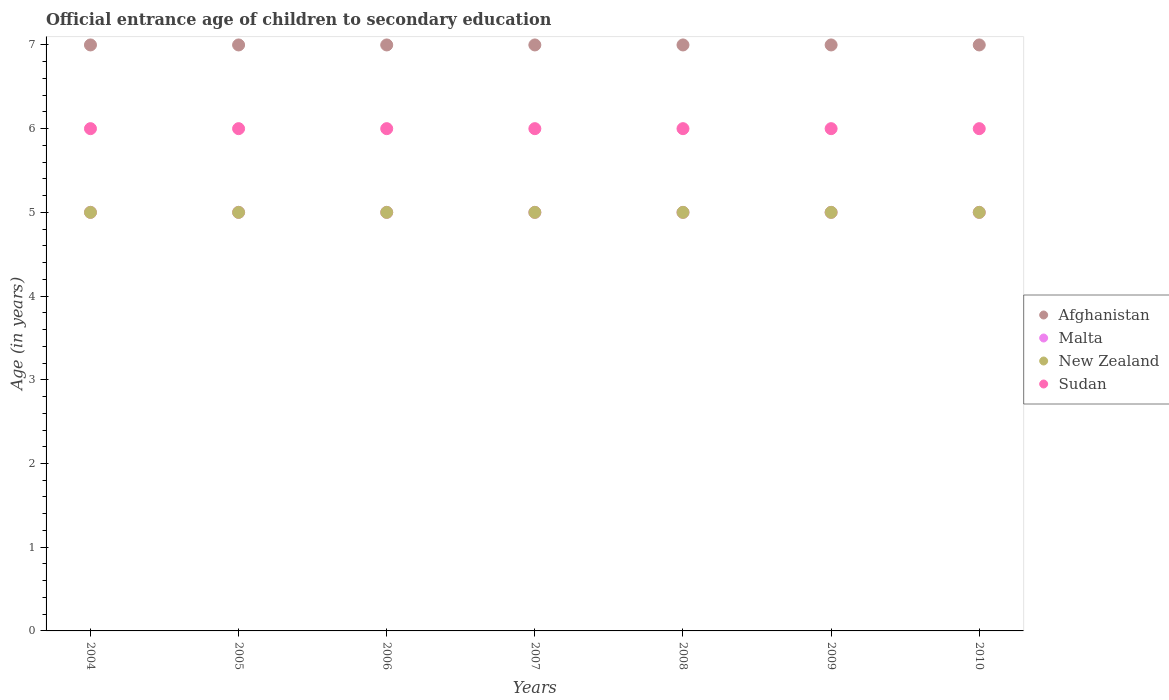Is the number of dotlines equal to the number of legend labels?
Provide a succinct answer. Yes. What is the secondary school starting age of children in Malta in 2010?
Keep it short and to the point. 5. Across all years, what is the maximum secondary school starting age of children in Malta?
Offer a terse response. 5. Across all years, what is the minimum secondary school starting age of children in Sudan?
Provide a succinct answer. 6. What is the total secondary school starting age of children in Afghanistan in the graph?
Provide a succinct answer. 49. In the year 2006, what is the difference between the secondary school starting age of children in Afghanistan and secondary school starting age of children in Sudan?
Make the answer very short. 1. What is the ratio of the secondary school starting age of children in Afghanistan in 2004 to that in 2008?
Your answer should be very brief. 1. Is the secondary school starting age of children in New Zealand in 2008 less than that in 2010?
Provide a short and direct response. No. In how many years, is the secondary school starting age of children in Malta greater than the average secondary school starting age of children in Malta taken over all years?
Offer a terse response. 0. Is the sum of the secondary school starting age of children in New Zealand in 2008 and 2010 greater than the maximum secondary school starting age of children in Sudan across all years?
Ensure brevity in your answer.  Yes. Is it the case that in every year, the sum of the secondary school starting age of children in Malta and secondary school starting age of children in New Zealand  is greater than the sum of secondary school starting age of children in Afghanistan and secondary school starting age of children in Sudan?
Offer a terse response. No. Is it the case that in every year, the sum of the secondary school starting age of children in Malta and secondary school starting age of children in New Zealand  is greater than the secondary school starting age of children in Sudan?
Provide a succinct answer. Yes. Does the secondary school starting age of children in Afghanistan monotonically increase over the years?
Your answer should be compact. No. Is the secondary school starting age of children in Afghanistan strictly greater than the secondary school starting age of children in Malta over the years?
Offer a very short reply. Yes. How many dotlines are there?
Offer a terse response. 4. What is the difference between two consecutive major ticks on the Y-axis?
Provide a succinct answer. 1. Are the values on the major ticks of Y-axis written in scientific E-notation?
Ensure brevity in your answer.  No. Does the graph contain any zero values?
Provide a succinct answer. No. Does the graph contain grids?
Offer a very short reply. No. How many legend labels are there?
Make the answer very short. 4. How are the legend labels stacked?
Give a very brief answer. Vertical. What is the title of the graph?
Your response must be concise. Official entrance age of children to secondary education. What is the label or title of the X-axis?
Give a very brief answer. Years. What is the label or title of the Y-axis?
Make the answer very short. Age (in years). What is the Age (in years) in Afghanistan in 2004?
Ensure brevity in your answer.  7. What is the Age (in years) of Malta in 2004?
Make the answer very short. 5. What is the Age (in years) of New Zealand in 2005?
Ensure brevity in your answer.  5. What is the Age (in years) of Sudan in 2005?
Offer a terse response. 6. What is the Age (in years) in New Zealand in 2006?
Offer a very short reply. 5. What is the Age (in years) in Afghanistan in 2007?
Your response must be concise. 7. What is the Age (in years) of Malta in 2007?
Make the answer very short. 5. What is the Age (in years) of New Zealand in 2007?
Your answer should be very brief. 5. What is the Age (in years) in Sudan in 2007?
Make the answer very short. 6. What is the Age (in years) in Malta in 2008?
Give a very brief answer. 5. What is the Age (in years) of Malta in 2010?
Your response must be concise. 5. What is the Age (in years) of New Zealand in 2010?
Make the answer very short. 5. What is the Age (in years) in Sudan in 2010?
Ensure brevity in your answer.  6. Across all years, what is the maximum Age (in years) in New Zealand?
Offer a very short reply. 5. Across all years, what is the minimum Age (in years) in Afghanistan?
Ensure brevity in your answer.  7. Across all years, what is the minimum Age (in years) of Malta?
Offer a very short reply. 5. Across all years, what is the minimum Age (in years) of New Zealand?
Your response must be concise. 5. What is the total Age (in years) of Afghanistan in the graph?
Your answer should be very brief. 49. What is the total Age (in years) of Malta in the graph?
Your answer should be compact. 35. What is the total Age (in years) in Sudan in the graph?
Offer a very short reply. 42. What is the difference between the Age (in years) of Afghanistan in 2004 and that in 2005?
Your response must be concise. 0. What is the difference between the Age (in years) of New Zealand in 2004 and that in 2005?
Keep it short and to the point. 0. What is the difference between the Age (in years) in Afghanistan in 2004 and that in 2006?
Provide a succinct answer. 0. What is the difference between the Age (in years) of New Zealand in 2004 and that in 2006?
Give a very brief answer. 0. What is the difference between the Age (in years) in New Zealand in 2004 and that in 2007?
Make the answer very short. 0. What is the difference between the Age (in years) of Sudan in 2004 and that in 2007?
Your answer should be very brief. 0. What is the difference between the Age (in years) of Malta in 2004 and that in 2008?
Your answer should be very brief. 0. What is the difference between the Age (in years) of New Zealand in 2004 and that in 2008?
Ensure brevity in your answer.  0. What is the difference between the Age (in years) of Afghanistan in 2004 and that in 2009?
Ensure brevity in your answer.  0. What is the difference between the Age (in years) in Malta in 2004 and that in 2009?
Provide a short and direct response. 0. What is the difference between the Age (in years) of Afghanistan in 2004 and that in 2010?
Your answer should be compact. 0. What is the difference between the Age (in years) of Malta in 2005 and that in 2007?
Your answer should be compact. 0. What is the difference between the Age (in years) in Sudan in 2005 and that in 2007?
Offer a very short reply. 0. What is the difference between the Age (in years) in Malta in 2005 and that in 2008?
Offer a very short reply. 0. What is the difference between the Age (in years) in New Zealand in 2005 and that in 2008?
Offer a terse response. 0. What is the difference between the Age (in years) of Afghanistan in 2005 and that in 2009?
Provide a succinct answer. 0. What is the difference between the Age (in years) of Sudan in 2005 and that in 2009?
Your answer should be very brief. 0. What is the difference between the Age (in years) of Afghanistan in 2005 and that in 2010?
Give a very brief answer. 0. What is the difference between the Age (in years) of Malta in 2005 and that in 2010?
Keep it short and to the point. 0. What is the difference between the Age (in years) of Sudan in 2005 and that in 2010?
Provide a succinct answer. 0. What is the difference between the Age (in years) of Afghanistan in 2006 and that in 2007?
Make the answer very short. 0. What is the difference between the Age (in years) in New Zealand in 2006 and that in 2008?
Give a very brief answer. 0. What is the difference between the Age (in years) of Afghanistan in 2006 and that in 2009?
Keep it short and to the point. 0. What is the difference between the Age (in years) in Afghanistan in 2006 and that in 2010?
Offer a very short reply. 0. What is the difference between the Age (in years) in Malta in 2006 and that in 2010?
Your answer should be compact. 0. What is the difference between the Age (in years) in New Zealand in 2006 and that in 2010?
Provide a succinct answer. 0. What is the difference between the Age (in years) in Afghanistan in 2007 and that in 2008?
Provide a short and direct response. 0. What is the difference between the Age (in years) of Sudan in 2007 and that in 2008?
Give a very brief answer. 0. What is the difference between the Age (in years) of Malta in 2007 and that in 2009?
Ensure brevity in your answer.  0. What is the difference between the Age (in years) in New Zealand in 2007 and that in 2009?
Offer a very short reply. 0. What is the difference between the Age (in years) in Afghanistan in 2007 and that in 2010?
Provide a short and direct response. 0. What is the difference between the Age (in years) of Afghanistan in 2008 and that in 2009?
Offer a very short reply. 0. What is the difference between the Age (in years) of Malta in 2008 and that in 2009?
Your answer should be compact. 0. What is the difference between the Age (in years) in New Zealand in 2008 and that in 2009?
Keep it short and to the point. 0. What is the difference between the Age (in years) of Sudan in 2008 and that in 2009?
Your answer should be very brief. 0. What is the difference between the Age (in years) in Afghanistan in 2008 and that in 2010?
Offer a very short reply. 0. What is the difference between the Age (in years) of Malta in 2008 and that in 2010?
Give a very brief answer. 0. What is the difference between the Age (in years) in New Zealand in 2008 and that in 2010?
Offer a very short reply. 0. What is the difference between the Age (in years) of Sudan in 2008 and that in 2010?
Make the answer very short. 0. What is the difference between the Age (in years) in Malta in 2009 and that in 2010?
Keep it short and to the point. 0. What is the difference between the Age (in years) of Afghanistan in 2004 and the Age (in years) of New Zealand in 2005?
Offer a terse response. 2. What is the difference between the Age (in years) in Malta in 2004 and the Age (in years) in New Zealand in 2005?
Your response must be concise. 0. What is the difference between the Age (in years) of New Zealand in 2004 and the Age (in years) of Sudan in 2005?
Your answer should be compact. -1. What is the difference between the Age (in years) of Afghanistan in 2004 and the Age (in years) of Sudan in 2006?
Your answer should be very brief. 1. What is the difference between the Age (in years) in New Zealand in 2004 and the Age (in years) in Sudan in 2006?
Your answer should be compact. -1. What is the difference between the Age (in years) in Afghanistan in 2004 and the Age (in years) in Sudan in 2007?
Your answer should be very brief. 1. What is the difference between the Age (in years) of Afghanistan in 2004 and the Age (in years) of Malta in 2008?
Your answer should be very brief. 2. What is the difference between the Age (in years) in Afghanistan in 2004 and the Age (in years) in New Zealand in 2008?
Ensure brevity in your answer.  2. What is the difference between the Age (in years) in Afghanistan in 2004 and the Age (in years) in Sudan in 2008?
Offer a terse response. 1. What is the difference between the Age (in years) of Malta in 2004 and the Age (in years) of New Zealand in 2008?
Offer a terse response. 0. What is the difference between the Age (in years) in Malta in 2004 and the Age (in years) in Sudan in 2008?
Ensure brevity in your answer.  -1. What is the difference between the Age (in years) in New Zealand in 2004 and the Age (in years) in Sudan in 2008?
Ensure brevity in your answer.  -1. What is the difference between the Age (in years) of Afghanistan in 2004 and the Age (in years) of Sudan in 2009?
Your answer should be compact. 1. What is the difference between the Age (in years) of Malta in 2004 and the Age (in years) of New Zealand in 2009?
Make the answer very short. 0. What is the difference between the Age (in years) in New Zealand in 2004 and the Age (in years) in Sudan in 2009?
Your answer should be compact. -1. What is the difference between the Age (in years) in Afghanistan in 2004 and the Age (in years) in Malta in 2010?
Keep it short and to the point. 2. What is the difference between the Age (in years) of Afghanistan in 2004 and the Age (in years) of Sudan in 2010?
Offer a terse response. 1. What is the difference between the Age (in years) in New Zealand in 2004 and the Age (in years) in Sudan in 2010?
Your answer should be very brief. -1. What is the difference between the Age (in years) of Afghanistan in 2005 and the Age (in years) of New Zealand in 2006?
Your response must be concise. 2. What is the difference between the Age (in years) of Malta in 2005 and the Age (in years) of New Zealand in 2006?
Your answer should be compact. 0. What is the difference between the Age (in years) in Afghanistan in 2005 and the Age (in years) in Malta in 2007?
Ensure brevity in your answer.  2. What is the difference between the Age (in years) in Malta in 2005 and the Age (in years) in Sudan in 2007?
Provide a succinct answer. -1. What is the difference between the Age (in years) of Afghanistan in 2005 and the Age (in years) of New Zealand in 2008?
Ensure brevity in your answer.  2. What is the difference between the Age (in years) in Afghanistan in 2005 and the Age (in years) in Sudan in 2008?
Offer a very short reply. 1. What is the difference between the Age (in years) of New Zealand in 2005 and the Age (in years) of Sudan in 2008?
Your response must be concise. -1. What is the difference between the Age (in years) in Afghanistan in 2005 and the Age (in years) in Malta in 2009?
Provide a succinct answer. 2. What is the difference between the Age (in years) in Afghanistan in 2005 and the Age (in years) in New Zealand in 2009?
Your answer should be very brief. 2. What is the difference between the Age (in years) in Afghanistan in 2005 and the Age (in years) in Sudan in 2009?
Give a very brief answer. 1. What is the difference between the Age (in years) in Malta in 2005 and the Age (in years) in New Zealand in 2009?
Keep it short and to the point. 0. What is the difference between the Age (in years) in Malta in 2005 and the Age (in years) in Sudan in 2009?
Your answer should be compact. -1. What is the difference between the Age (in years) of Afghanistan in 2006 and the Age (in years) of Sudan in 2007?
Make the answer very short. 1. What is the difference between the Age (in years) of Malta in 2006 and the Age (in years) of New Zealand in 2007?
Keep it short and to the point. 0. What is the difference between the Age (in years) in Afghanistan in 2006 and the Age (in years) in New Zealand in 2008?
Offer a very short reply. 2. What is the difference between the Age (in years) in Malta in 2006 and the Age (in years) in New Zealand in 2008?
Keep it short and to the point. 0. What is the difference between the Age (in years) in New Zealand in 2006 and the Age (in years) in Sudan in 2009?
Your response must be concise. -1. What is the difference between the Age (in years) of Afghanistan in 2006 and the Age (in years) of New Zealand in 2010?
Offer a very short reply. 2. What is the difference between the Age (in years) of Malta in 2006 and the Age (in years) of New Zealand in 2010?
Your answer should be very brief. 0. What is the difference between the Age (in years) in Malta in 2006 and the Age (in years) in Sudan in 2010?
Offer a terse response. -1. What is the difference between the Age (in years) in New Zealand in 2006 and the Age (in years) in Sudan in 2010?
Keep it short and to the point. -1. What is the difference between the Age (in years) in Malta in 2007 and the Age (in years) in Sudan in 2008?
Offer a terse response. -1. What is the difference between the Age (in years) of Afghanistan in 2007 and the Age (in years) of New Zealand in 2009?
Offer a very short reply. 2. What is the difference between the Age (in years) of Malta in 2007 and the Age (in years) of New Zealand in 2009?
Ensure brevity in your answer.  0. What is the difference between the Age (in years) of Afghanistan in 2007 and the Age (in years) of New Zealand in 2010?
Your answer should be compact. 2. What is the difference between the Age (in years) in Malta in 2007 and the Age (in years) in New Zealand in 2010?
Your answer should be very brief. 0. What is the difference between the Age (in years) in Afghanistan in 2008 and the Age (in years) in Malta in 2009?
Offer a terse response. 2. What is the difference between the Age (in years) of Afghanistan in 2008 and the Age (in years) of New Zealand in 2009?
Give a very brief answer. 2. What is the difference between the Age (in years) in Malta in 2008 and the Age (in years) in Sudan in 2009?
Keep it short and to the point. -1. What is the difference between the Age (in years) of New Zealand in 2008 and the Age (in years) of Sudan in 2009?
Provide a short and direct response. -1. What is the difference between the Age (in years) of Afghanistan in 2008 and the Age (in years) of New Zealand in 2010?
Give a very brief answer. 2. What is the difference between the Age (in years) of Malta in 2008 and the Age (in years) of Sudan in 2010?
Your response must be concise. -1. What is the difference between the Age (in years) of New Zealand in 2008 and the Age (in years) of Sudan in 2010?
Offer a very short reply. -1. What is the difference between the Age (in years) of Afghanistan in 2009 and the Age (in years) of Malta in 2010?
Give a very brief answer. 2. What is the difference between the Age (in years) of Afghanistan in 2009 and the Age (in years) of New Zealand in 2010?
Your answer should be very brief. 2. What is the difference between the Age (in years) of Afghanistan in 2009 and the Age (in years) of Sudan in 2010?
Offer a terse response. 1. What is the difference between the Age (in years) in Malta in 2009 and the Age (in years) in New Zealand in 2010?
Offer a terse response. 0. What is the difference between the Age (in years) in Malta in 2009 and the Age (in years) in Sudan in 2010?
Your answer should be compact. -1. What is the difference between the Age (in years) in New Zealand in 2009 and the Age (in years) in Sudan in 2010?
Your response must be concise. -1. In the year 2004, what is the difference between the Age (in years) of Afghanistan and Age (in years) of Malta?
Provide a succinct answer. 2. In the year 2004, what is the difference between the Age (in years) in Afghanistan and Age (in years) in New Zealand?
Give a very brief answer. 2. In the year 2004, what is the difference between the Age (in years) in Malta and Age (in years) in New Zealand?
Keep it short and to the point. 0. In the year 2005, what is the difference between the Age (in years) of Afghanistan and Age (in years) of New Zealand?
Offer a very short reply. 2. In the year 2005, what is the difference between the Age (in years) of Afghanistan and Age (in years) of Sudan?
Keep it short and to the point. 1. In the year 2005, what is the difference between the Age (in years) of Malta and Age (in years) of New Zealand?
Ensure brevity in your answer.  0. In the year 2005, what is the difference between the Age (in years) of New Zealand and Age (in years) of Sudan?
Ensure brevity in your answer.  -1. In the year 2006, what is the difference between the Age (in years) of Afghanistan and Age (in years) of Sudan?
Offer a very short reply. 1. In the year 2007, what is the difference between the Age (in years) in Afghanistan and Age (in years) in New Zealand?
Your answer should be compact. 2. In the year 2007, what is the difference between the Age (in years) in Afghanistan and Age (in years) in Sudan?
Give a very brief answer. 1. In the year 2007, what is the difference between the Age (in years) in Malta and Age (in years) in New Zealand?
Your answer should be compact. 0. In the year 2007, what is the difference between the Age (in years) in Malta and Age (in years) in Sudan?
Make the answer very short. -1. In the year 2007, what is the difference between the Age (in years) of New Zealand and Age (in years) of Sudan?
Offer a very short reply. -1. In the year 2008, what is the difference between the Age (in years) in Afghanistan and Age (in years) in Malta?
Keep it short and to the point. 2. In the year 2008, what is the difference between the Age (in years) in Malta and Age (in years) in New Zealand?
Offer a terse response. 0. In the year 2009, what is the difference between the Age (in years) of Afghanistan and Age (in years) of Malta?
Your response must be concise. 2. In the year 2009, what is the difference between the Age (in years) in Afghanistan and Age (in years) in Sudan?
Make the answer very short. 1. In the year 2009, what is the difference between the Age (in years) in New Zealand and Age (in years) in Sudan?
Ensure brevity in your answer.  -1. In the year 2010, what is the difference between the Age (in years) of Malta and Age (in years) of New Zealand?
Keep it short and to the point. 0. In the year 2010, what is the difference between the Age (in years) of Malta and Age (in years) of Sudan?
Provide a short and direct response. -1. In the year 2010, what is the difference between the Age (in years) of New Zealand and Age (in years) of Sudan?
Your answer should be very brief. -1. What is the ratio of the Age (in years) of New Zealand in 2004 to that in 2006?
Offer a very short reply. 1. What is the ratio of the Age (in years) of Malta in 2004 to that in 2007?
Provide a succinct answer. 1. What is the ratio of the Age (in years) in Sudan in 2004 to that in 2007?
Offer a very short reply. 1. What is the ratio of the Age (in years) of Afghanistan in 2004 to that in 2008?
Your answer should be very brief. 1. What is the ratio of the Age (in years) in Sudan in 2004 to that in 2008?
Give a very brief answer. 1. What is the ratio of the Age (in years) of Malta in 2004 to that in 2009?
Your answer should be compact. 1. What is the ratio of the Age (in years) of New Zealand in 2004 to that in 2009?
Ensure brevity in your answer.  1. What is the ratio of the Age (in years) in Sudan in 2004 to that in 2009?
Offer a very short reply. 1. What is the ratio of the Age (in years) of Afghanistan in 2005 to that in 2006?
Offer a very short reply. 1. What is the ratio of the Age (in years) of Malta in 2005 to that in 2006?
Give a very brief answer. 1. What is the ratio of the Age (in years) of Malta in 2005 to that in 2007?
Your answer should be compact. 1. What is the ratio of the Age (in years) in Afghanistan in 2005 to that in 2008?
Your answer should be compact. 1. What is the ratio of the Age (in years) in Sudan in 2005 to that in 2008?
Provide a succinct answer. 1. What is the ratio of the Age (in years) in Afghanistan in 2005 to that in 2009?
Give a very brief answer. 1. What is the ratio of the Age (in years) in Malta in 2005 to that in 2009?
Offer a terse response. 1. What is the ratio of the Age (in years) of New Zealand in 2005 to that in 2010?
Provide a succinct answer. 1. What is the ratio of the Age (in years) in Sudan in 2005 to that in 2010?
Provide a succinct answer. 1. What is the ratio of the Age (in years) in Afghanistan in 2006 to that in 2007?
Provide a succinct answer. 1. What is the ratio of the Age (in years) in New Zealand in 2006 to that in 2007?
Keep it short and to the point. 1. What is the ratio of the Age (in years) in Sudan in 2006 to that in 2007?
Provide a succinct answer. 1. What is the ratio of the Age (in years) of Afghanistan in 2006 to that in 2008?
Keep it short and to the point. 1. What is the ratio of the Age (in years) of Malta in 2006 to that in 2008?
Give a very brief answer. 1. What is the ratio of the Age (in years) of Malta in 2006 to that in 2009?
Give a very brief answer. 1. What is the ratio of the Age (in years) in New Zealand in 2006 to that in 2009?
Your answer should be very brief. 1. What is the ratio of the Age (in years) in Malta in 2006 to that in 2010?
Keep it short and to the point. 1. What is the ratio of the Age (in years) of Afghanistan in 2007 to that in 2008?
Ensure brevity in your answer.  1. What is the ratio of the Age (in years) of Malta in 2007 to that in 2008?
Offer a terse response. 1. What is the ratio of the Age (in years) in Sudan in 2007 to that in 2008?
Provide a short and direct response. 1. What is the ratio of the Age (in years) in Malta in 2007 to that in 2009?
Your answer should be compact. 1. What is the ratio of the Age (in years) in Sudan in 2007 to that in 2009?
Your answer should be very brief. 1. What is the ratio of the Age (in years) in Afghanistan in 2008 to that in 2009?
Give a very brief answer. 1. What is the ratio of the Age (in years) in New Zealand in 2008 to that in 2009?
Give a very brief answer. 1. What is the ratio of the Age (in years) in Malta in 2008 to that in 2010?
Offer a terse response. 1. What is the ratio of the Age (in years) in New Zealand in 2008 to that in 2010?
Your answer should be compact. 1. What is the ratio of the Age (in years) in Sudan in 2008 to that in 2010?
Make the answer very short. 1. What is the ratio of the Age (in years) in Afghanistan in 2009 to that in 2010?
Keep it short and to the point. 1. What is the difference between the highest and the second highest Age (in years) of Afghanistan?
Offer a terse response. 0. What is the difference between the highest and the second highest Age (in years) in Malta?
Make the answer very short. 0. What is the difference between the highest and the second highest Age (in years) of Sudan?
Your answer should be very brief. 0. 